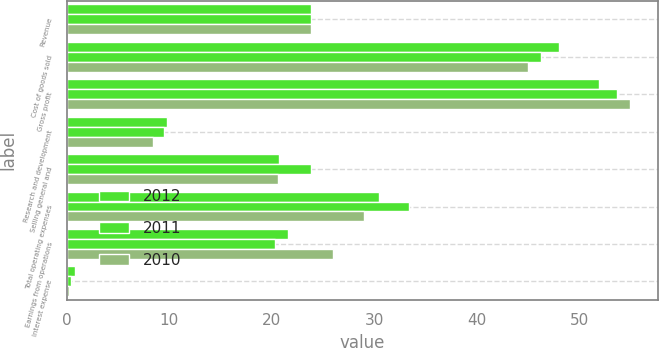Convert chart to OTSL. <chart><loc_0><loc_0><loc_500><loc_500><stacked_bar_chart><ecel><fcel>Revenue<fcel>Cost of goods sold<fcel>Gross profit<fcel>Research and development<fcel>Selling general and<fcel>Total operating expenses<fcel>Earnings from operations<fcel>Interest expense<nl><fcel>2012<fcel>23.8<fcel>48<fcel>52<fcel>9.8<fcel>20.7<fcel>30.5<fcel>21.6<fcel>0.8<nl><fcel>2011<fcel>23.8<fcel>46.3<fcel>53.7<fcel>9.5<fcel>23.8<fcel>33.4<fcel>20.3<fcel>0.4<nl><fcel>2010<fcel>23.8<fcel>45<fcel>55<fcel>8.4<fcel>20.6<fcel>29<fcel>26<fcel>0.2<nl></chart> 